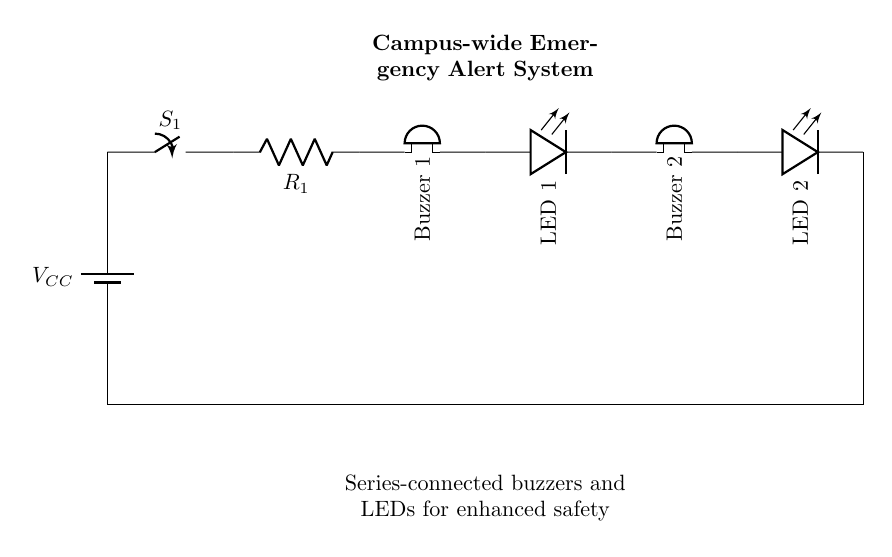What is the power supply in this circuit? The power supply is indicated as the battery labeled VCC, which provides the necessary voltage for the circuit.
Answer: VCC How many buzzers are in this circuit? The circuit includes two buzzers, as shown in the connections labeled "Buzzer 1" and "Buzzer 2."
Answer: 2 What components are connected in series in this circuit? In this circuit, the components connected in series are the two buzzers and two LEDs, which form a continuous path for current flow.
Answer: Buzzers and LEDs What happens if one component fails in this series circuit? If one component, such as a buzzer or LED, fails, it will break the circuit, causing all components in the series to stop functioning because the current cannot continue flowing.
Answer: All components stop What is the function of the switch in this circuit? The switch, labeled S1, acts as a control mechanism to open or close the circuit, thus enabling or disabling the entire emergency alert system.
Answer: Control mechanism How does the current flow in this series circuit? In a series circuit, the current flows in a single path through each component sequentially. In this circuit, current starts at the battery, passes through the switch, resistor, buzzers, LEDs, and finally returns to ground.
Answer: One path 